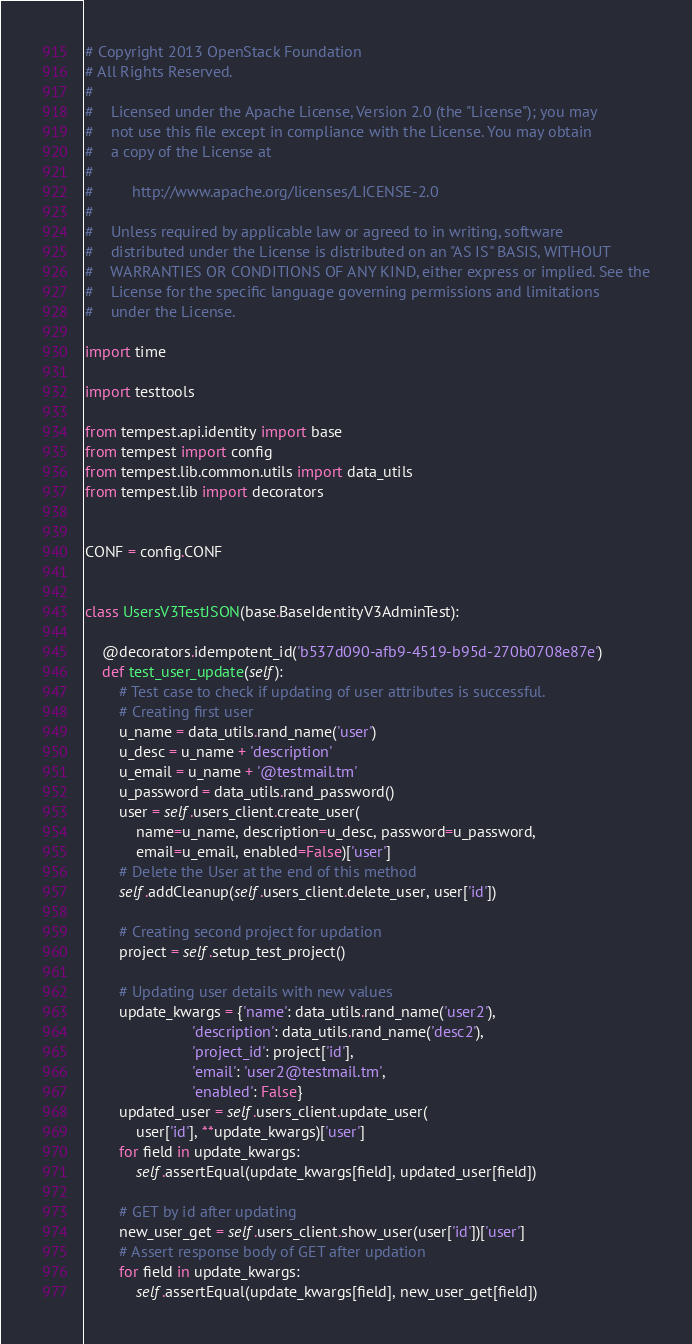<code> <loc_0><loc_0><loc_500><loc_500><_Python_># Copyright 2013 OpenStack Foundation
# All Rights Reserved.
#
#    Licensed under the Apache License, Version 2.0 (the "License"); you may
#    not use this file except in compliance with the License. You may obtain
#    a copy of the License at
#
#         http://www.apache.org/licenses/LICENSE-2.0
#
#    Unless required by applicable law or agreed to in writing, software
#    distributed under the License is distributed on an "AS IS" BASIS, WITHOUT
#    WARRANTIES OR CONDITIONS OF ANY KIND, either express or implied. See the
#    License for the specific language governing permissions and limitations
#    under the License.

import time

import testtools

from tempest.api.identity import base
from tempest import config
from tempest.lib.common.utils import data_utils
from tempest.lib import decorators


CONF = config.CONF


class UsersV3TestJSON(base.BaseIdentityV3AdminTest):

    @decorators.idempotent_id('b537d090-afb9-4519-b95d-270b0708e87e')
    def test_user_update(self):
        # Test case to check if updating of user attributes is successful.
        # Creating first user
        u_name = data_utils.rand_name('user')
        u_desc = u_name + 'description'
        u_email = u_name + '@testmail.tm'
        u_password = data_utils.rand_password()
        user = self.users_client.create_user(
            name=u_name, description=u_desc, password=u_password,
            email=u_email, enabled=False)['user']
        # Delete the User at the end of this method
        self.addCleanup(self.users_client.delete_user, user['id'])

        # Creating second project for updation
        project = self.setup_test_project()

        # Updating user details with new values
        update_kwargs = {'name': data_utils.rand_name('user2'),
                         'description': data_utils.rand_name('desc2'),
                         'project_id': project['id'],
                         'email': 'user2@testmail.tm',
                         'enabled': False}
        updated_user = self.users_client.update_user(
            user['id'], **update_kwargs)['user']
        for field in update_kwargs:
            self.assertEqual(update_kwargs[field], updated_user[field])

        # GET by id after updating
        new_user_get = self.users_client.show_user(user['id'])['user']
        # Assert response body of GET after updation
        for field in update_kwargs:
            self.assertEqual(update_kwargs[field], new_user_get[field])
</code> 